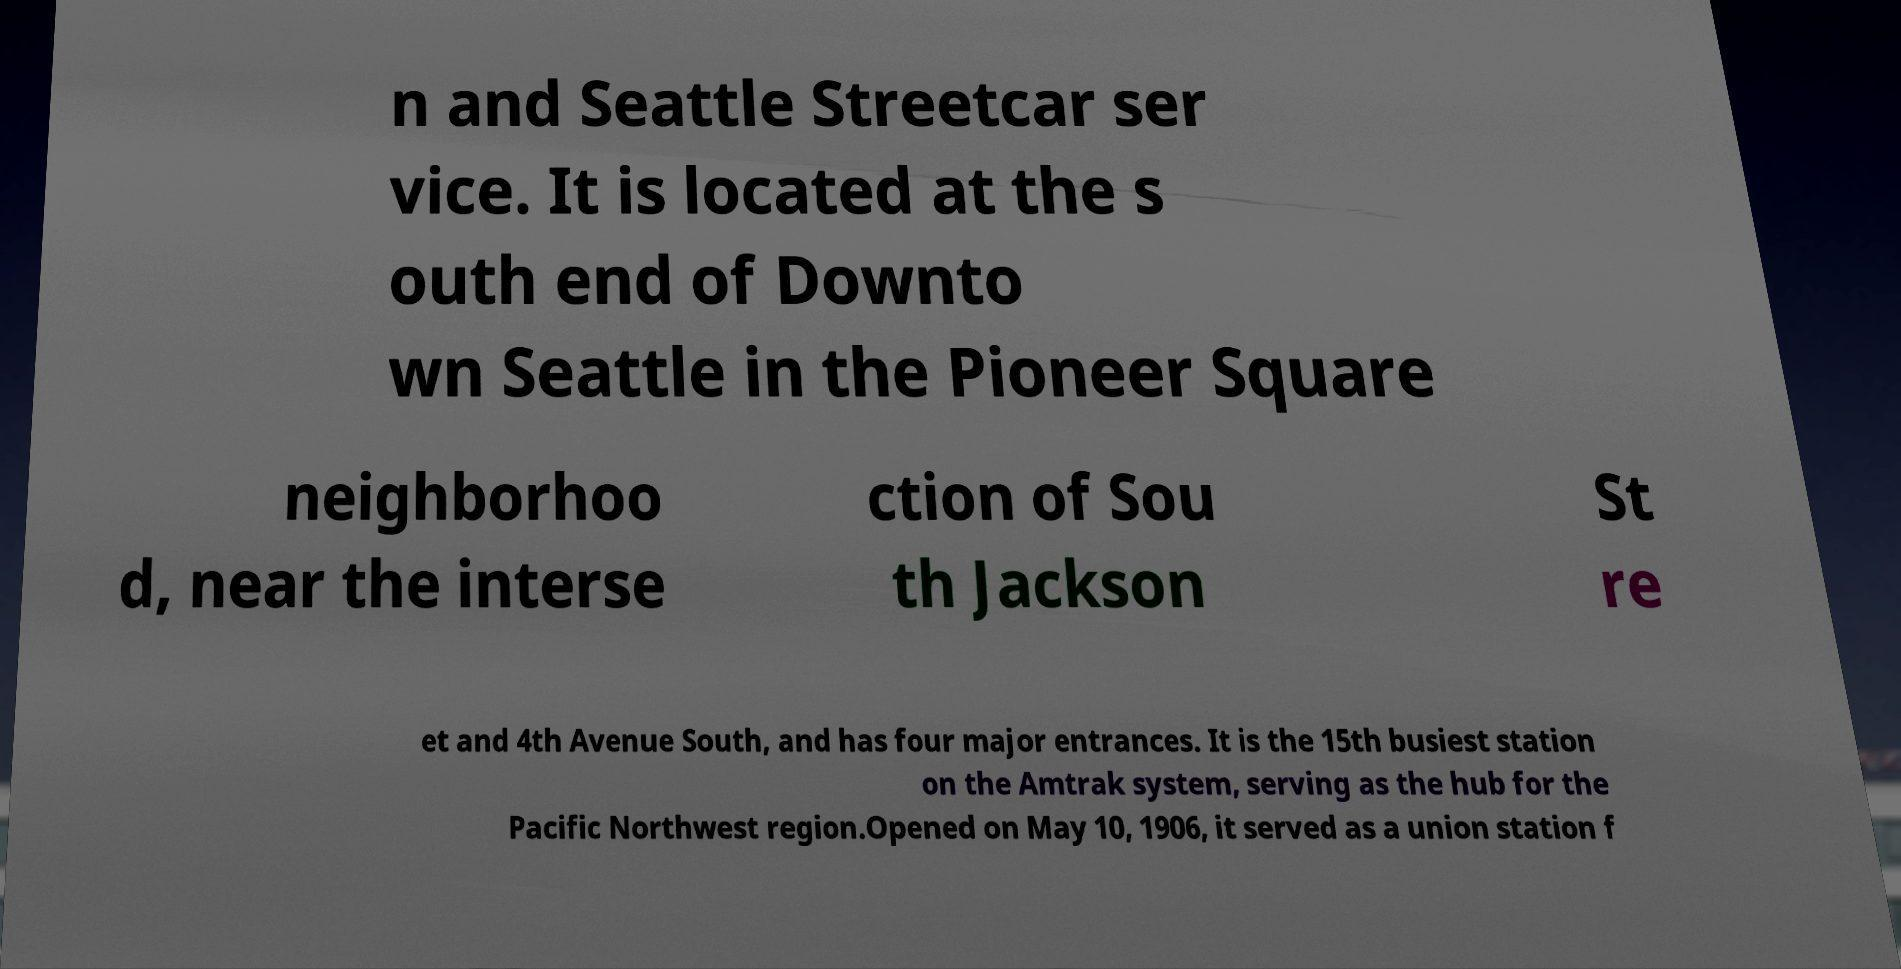Please read and relay the text visible in this image. What does it say? n and Seattle Streetcar ser vice. It is located at the s outh end of Downto wn Seattle in the Pioneer Square neighborhoo d, near the interse ction of Sou th Jackson St re et and 4th Avenue South, and has four major entrances. It is the 15th busiest station on the Amtrak system, serving as the hub for the Pacific Northwest region.Opened on May 10, 1906, it served as a union station f 